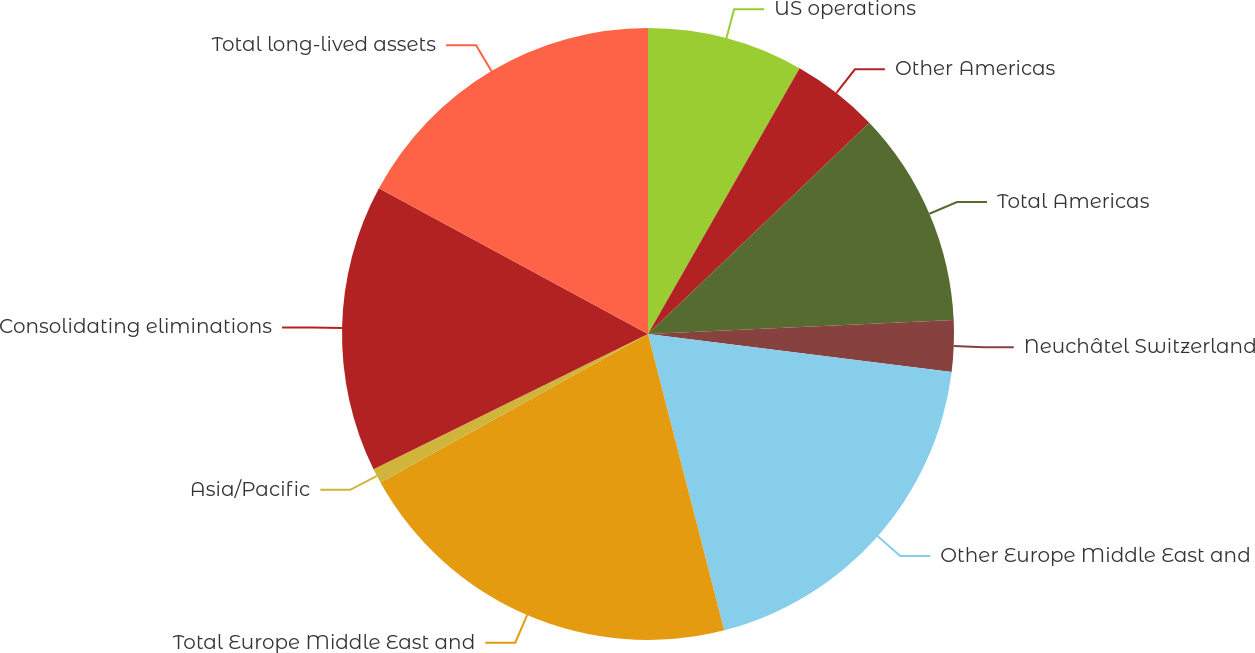Convert chart. <chart><loc_0><loc_0><loc_500><loc_500><pie_chart><fcel>US operations<fcel>Other Americas<fcel>Total Americas<fcel>Neuchâtel Switzerland<fcel>Other Europe Middle East and<fcel>Total Europe Middle East and<fcel>Asia/Pacific<fcel>Consolidating eliminations<fcel>Total long-lived assets<nl><fcel>8.25%<fcel>4.62%<fcel>11.41%<fcel>2.7%<fcel>19.02%<fcel>20.94%<fcel>0.78%<fcel>15.19%<fcel>17.1%<nl></chart> 